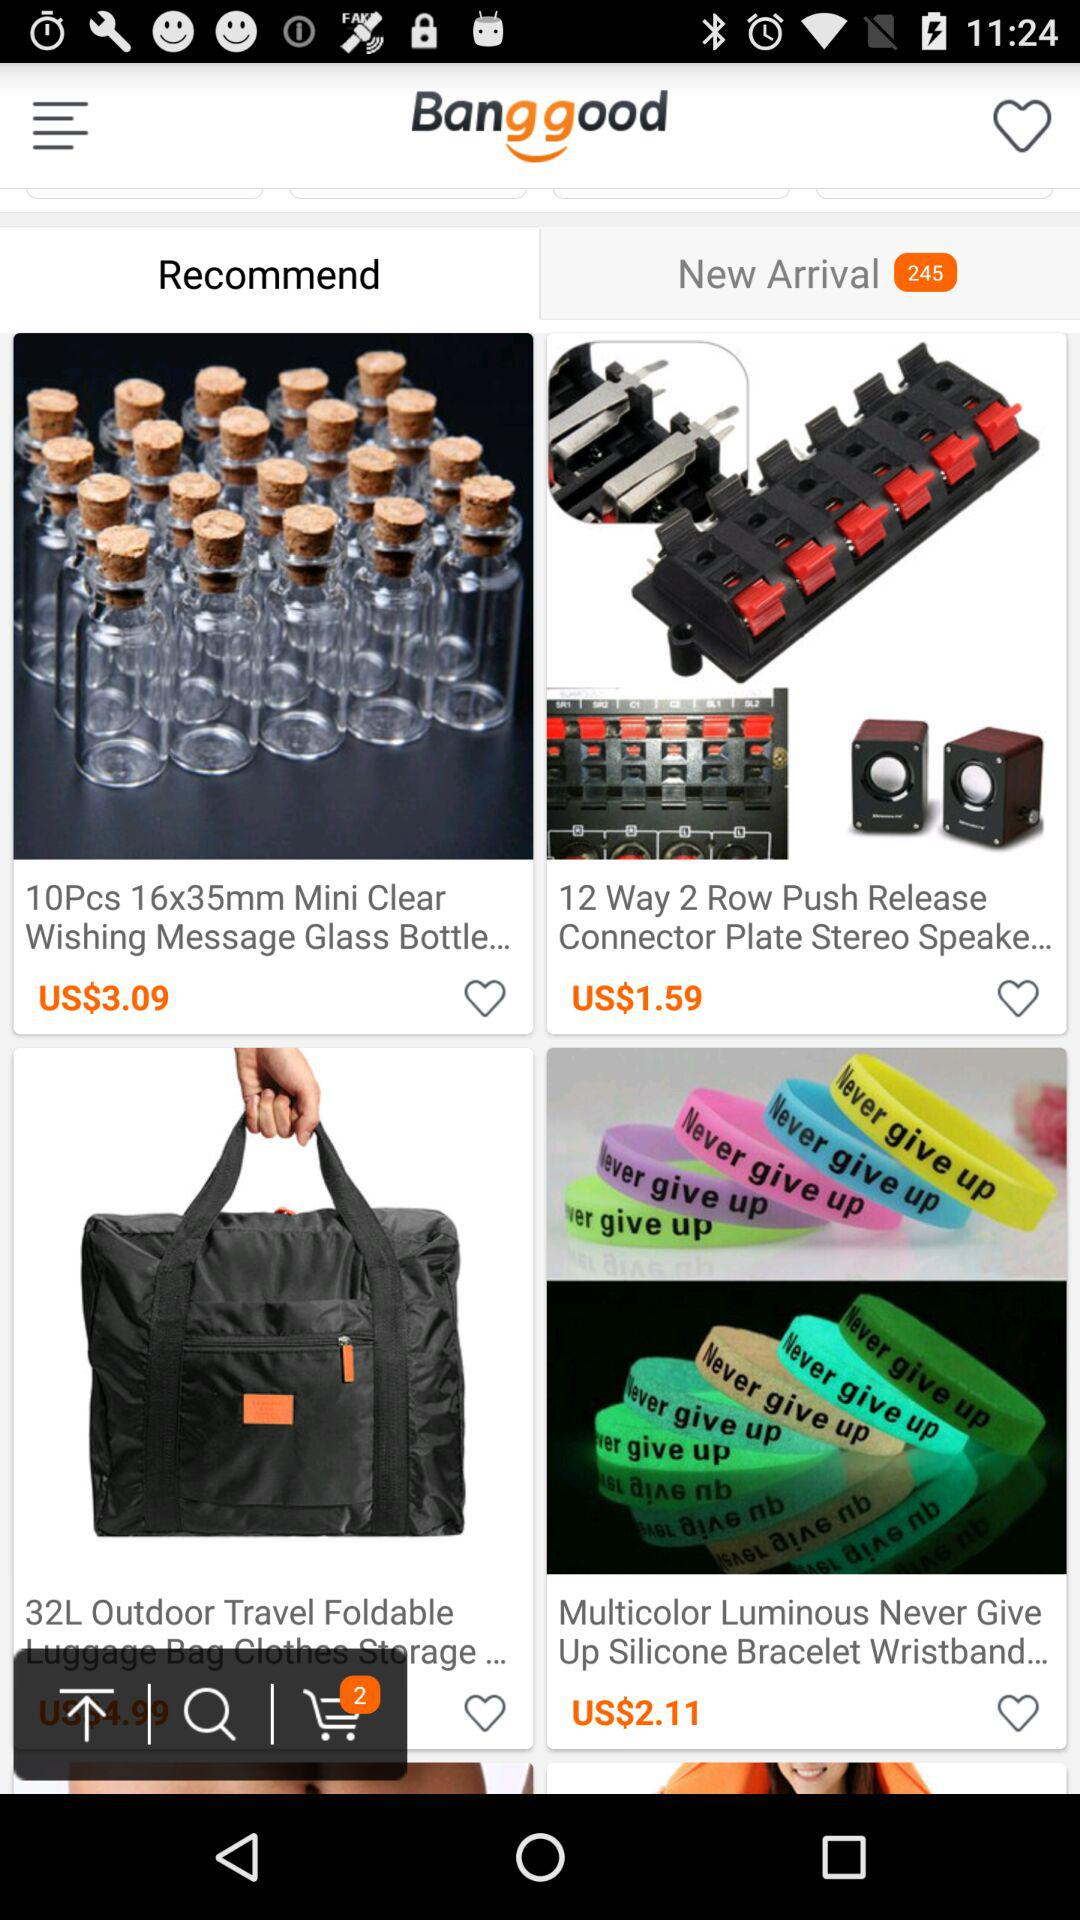How many items in the shopping cart?
Answer the question using a single word or phrase. 2 